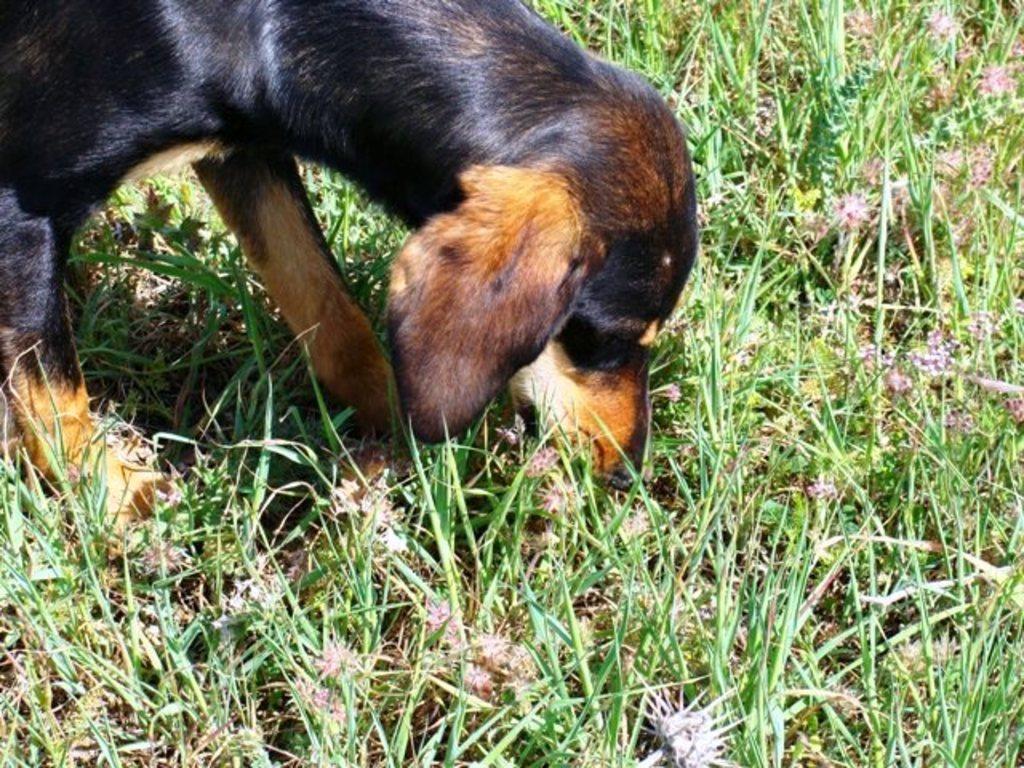Could you give a brief overview of what you see in this image? In this image I can see a dog standing on the grass ground. 